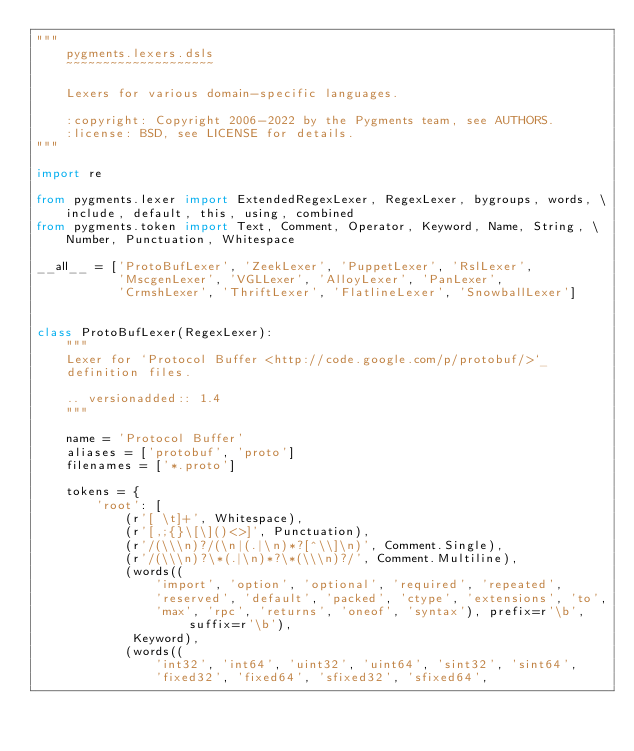Convert code to text. <code><loc_0><loc_0><loc_500><loc_500><_Python_>"""
    pygments.lexers.dsls
    ~~~~~~~~~~~~~~~~~~~~

    Lexers for various domain-specific languages.

    :copyright: Copyright 2006-2022 by the Pygments team, see AUTHORS.
    :license: BSD, see LICENSE for details.
"""

import re

from pygments.lexer import ExtendedRegexLexer, RegexLexer, bygroups, words, \
    include, default, this, using, combined
from pygments.token import Text, Comment, Operator, Keyword, Name, String, \
    Number, Punctuation, Whitespace

__all__ = ['ProtoBufLexer', 'ZeekLexer', 'PuppetLexer', 'RslLexer',
           'MscgenLexer', 'VGLLexer', 'AlloyLexer', 'PanLexer',
           'CrmshLexer', 'ThriftLexer', 'FlatlineLexer', 'SnowballLexer']


class ProtoBufLexer(RegexLexer):
    """
    Lexer for `Protocol Buffer <http://code.google.com/p/protobuf/>`_
    definition files.

    .. versionadded:: 1.4
    """

    name = 'Protocol Buffer'
    aliases = ['protobuf', 'proto']
    filenames = ['*.proto']

    tokens = {
        'root': [
            (r'[ \t]+', Whitespace),
            (r'[,;{}\[\]()<>]', Punctuation),
            (r'/(\\\n)?/(\n|(.|\n)*?[^\\]\n)', Comment.Single),
            (r'/(\\\n)?\*(.|\n)*?\*(\\\n)?/', Comment.Multiline),
            (words((
                'import', 'option', 'optional', 'required', 'repeated',
                'reserved', 'default', 'packed', 'ctype', 'extensions', 'to',
                'max', 'rpc', 'returns', 'oneof', 'syntax'), prefix=r'\b', suffix=r'\b'),
             Keyword),
            (words((
                'int32', 'int64', 'uint32', 'uint64', 'sint32', 'sint64',
                'fixed32', 'fixed64', 'sfixed32', 'sfixed64',</code> 